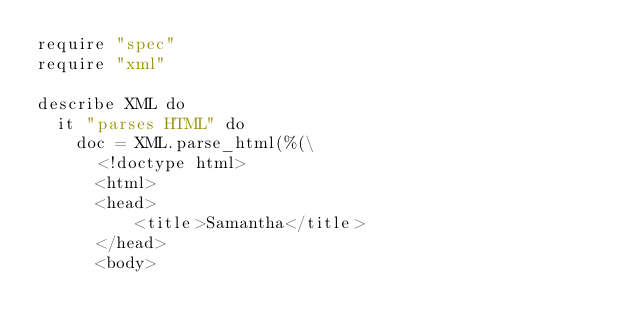<code> <loc_0><loc_0><loc_500><loc_500><_Crystal_>require "spec"
require "xml"

describe XML do
  it "parses HTML" do
    doc = XML.parse_html(%(\
      <!doctype html>
      <html>
      <head>
          <title>Samantha</title>
      </head>
      <body></code> 